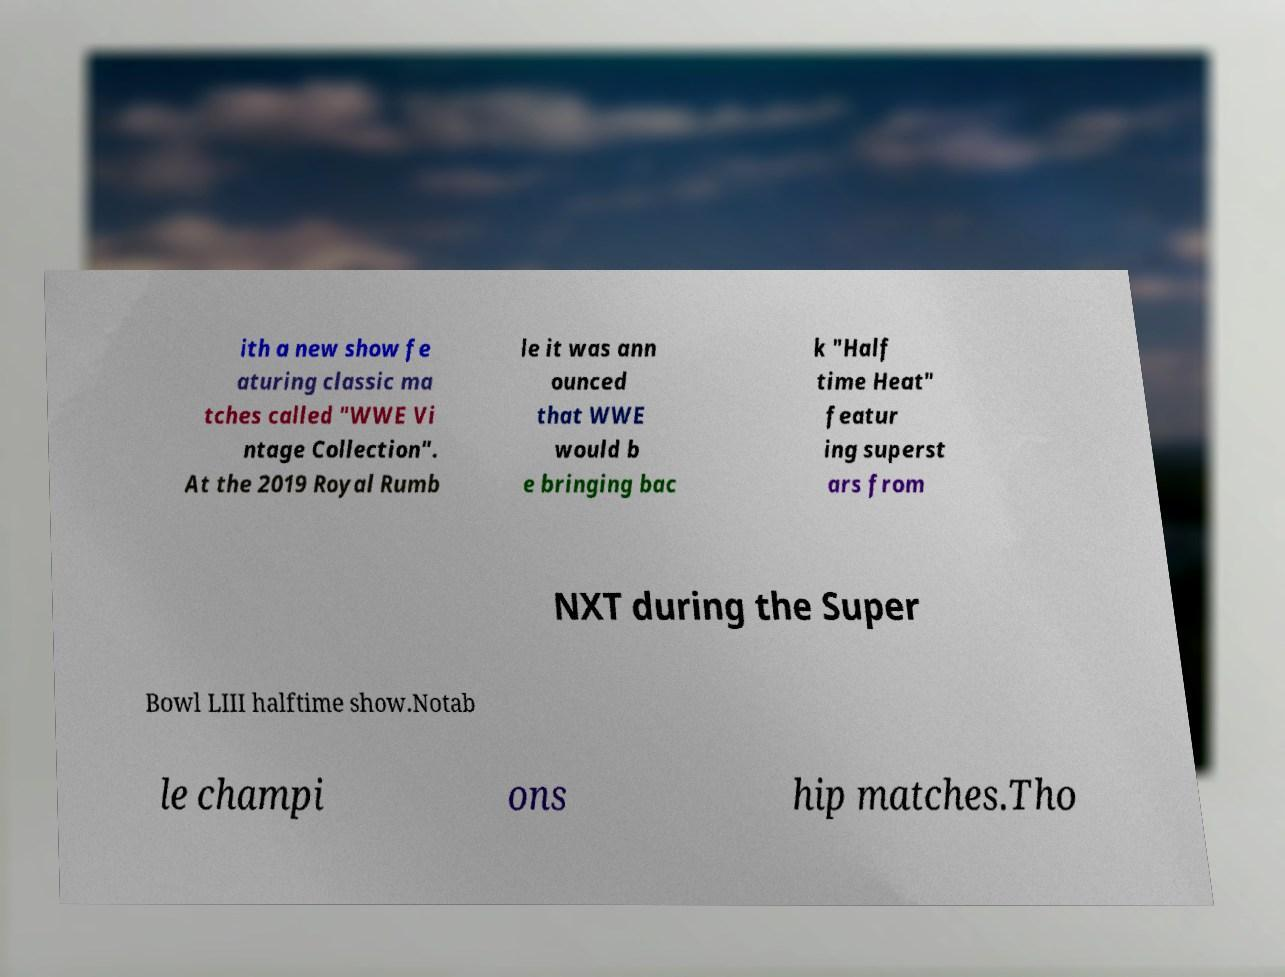What messages or text are displayed in this image? I need them in a readable, typed format. ith a new show fe aturing classic ma tches called "WWE Vi ntage Collection". At the 2019 Royal Rumb le it was ann ounced that WWE would b e bringing bac k "Half time Heat" featur ing superst ars from NXT during the Super Bowl LIII halftime show.Notab le champi ons hip matches.Tho 